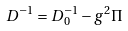<formula> <loc_0><loc_0><loc_500><loc_500>D ^ { - 1 } = D _ { 0 } ^ { - 1 } - g ^ { 2 } \Pi</formula> 